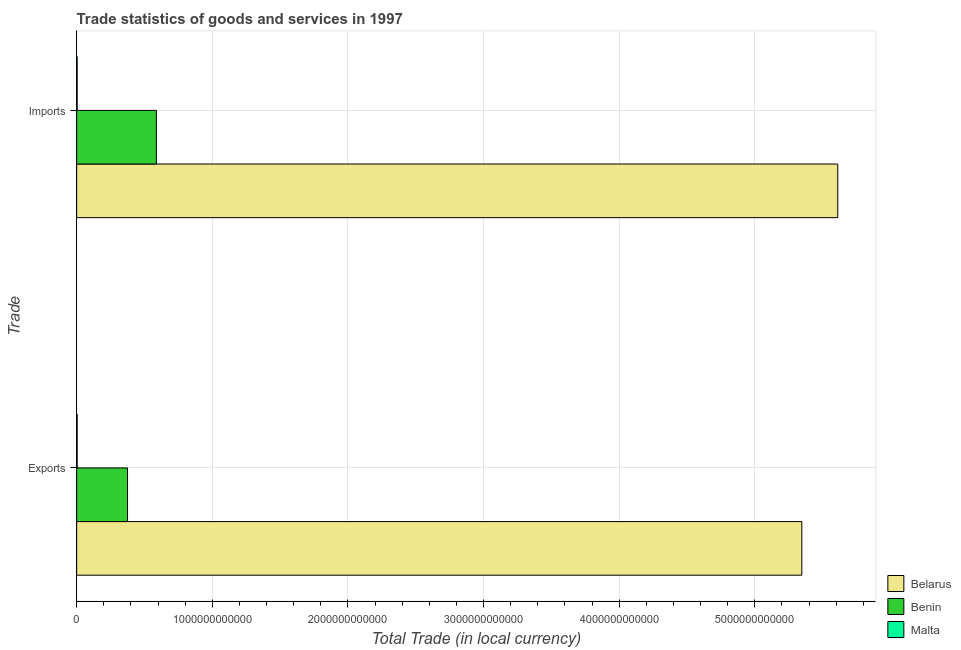How many different coloured bars are there?
Offer a terse response. 3. Are the number of bars per tick equal to the number of legend labels?
Your response must be concise. Yes. How many bars are there on the 2nd tick from the top?
Give a very brief answer. 3. How many bars are there on the 2nd tick from the bottom?
Provide a succinct answer. 3. What is the label of the 2nd group of bars from the top?
Offer a terse response. Exports. What is the imports of goods and services in Malta?
Offer a terse response. 3.81e+09. Across all countries, what is the maximum imports of goods and services?
Provide a succinct answer. 5.61e+12. Across all countries, what is the minimum imports of goods and services?
Your response must be concise. 3.81e+09. In which country was the imports of goods and services maximum?
Keep it short and to the point. Belarus. In which country was the export of goods and services minimum?
Provide a succinct answer. Malta. What is the total imports of goods and services in the graph?
Offer a terse response. 6.20e+12. What is the difference between the imports of goods and services in Benin and that in Belarus?
Your response must be concise. -5.02e+12. What is the difference between the imports of goods and services in Belarus and the export of goods and services in Benin?
Offer a terse response. 5.24e+12. What is the average imports of goods and services per country?
Keep it short and to the point. 2.07e+12. What is the difference between the export of goods and services and imports of goods and services in Belarus?
Keep it short and to the point. -2.65e+11. What is the ratio of the export of goods and services in Malta to that in Benin?
Give a very brief answer. 0.01. Is the imports of goods and services in Benin less than that in Belarus?
Give a very brief answer. Yes. In how many countries, is the imports of goods and services greater than the average imports of goods and services taken over all countries?
Provide a succinct answer. 1. What does the 2nd bar from the top in Exports represents?
Make the answer very short. Benin. What does the 3rd bar from the bottom in Exports represents?
Give a very brief answer. Malta. What is the difference between two consecutive major ticks on the X-axis?
Provide a short and direct response. 1.00e+12. Does the graph contain any zero values?
Provide a short and direct response. No. Does the graph contain grids?
Make the answer very short. Yes. Where does the legend appear in the graph?
Your response must be concise. Bottom right. How many legend labels are there?
Your answer should be very brief. 3. What is the title of the graph?
Offer a very short reply. Trade statistics of goods and services in 1997. Does "Qatar" appear as one of the legend labels in the graph?
Provide a succinct answer. No. What is the label or title of the X-axis?
Keep it short and to the point. Total Trade (in local currency). What is the label or title of the Y-axis?
Give a very brief answer. Trade. What is the Total Trade (in local currency) in Belarus in Exports?
Provide a succinct answer. 5.35e+12. What is the Total Trade (in local currency) in Benin in Exports?
Provide a succinct answer. 3.75e+11. What is the Total Trade (in local currency) of Malta in Exports?
Make the answer very short. 3.67e+09. What is the Total Trade (in local currency) of Belarus in Imports?
Keep it short and to the point. 5.61e+12. What is the Total Trade (in local currency) of Benin in Imports?
Your response must be concise. 5.88e+11. What is the Total Trade (in local currency) of Malta in Imports?
Make the answer very short. 3.81e+09. Across all Trade, what is the maximum Total Trade (in local currency) of Belarus?
Keep it short and to the point. 5.61e+12. Across all Trade, what is the maximum Total Trade (in local currency) in Benin?
Make the answer very short. 5.88e+11. Across all Trade, what is the maximum Total Trade (in local currency) in Malta?
Your answer should be compact. 3.81e+09. Across all Trade, what is the minimum Total Trade (in local currency) of Belarus?
Provide a short and direct response. 5.35e+12. Across all Trade, what is the minimum Total Trade (in local currency) in Benin?
Keep it short and to the point. 3.75e+11. Across all Trade, what is the minimum Total Trade (in local currency) of Malta?
Offer a terse response. 3.67e+09. What is the total Total Trade (in local currency) in Belarus in the graph?
Offer a terse response. 1.10e+13. What is the total Total Trade (in local currency) in Benin in the graph?
Make the answer very short. 9.63e+11. What is the total Total Trade (in local currency) of Malta in the graph?
Offer a very short reply. 7.48e+09. What is the difference between the Total Trade (in local currency) of Belarus in Exports and that in Imports?
Offer a very short reply. -2.65e+11. What is the difference between the Total Trade (in local currency) of Benin in Exports and that in Imports?
Provide a short and direct response. -2.13e+11. What is the difference between the Total Trade (in local currency) in Malta in Exports and that in Imports?
Your answer should be compact. -1.49e+08. What is the difference between the Total Trade (in local currency) in Belarus in Exports and the Total Trade (in local currency) in Benin in Imports?
Ensure brevity in your answer.  4.76e+12. What is the difference between the Total Trade (in local currency) of Belarus in Exports and the Total Trade (in local currency) of Malta in Imports?
Provide a succinct answer. 5.34e+12. What is the difference between the Total Trade (in local currency) of Benin in Exports and the Total Trade (in local currency) of Malta in Imports?
Give a very brief answer. 3.71e+11. What is the average Total Trade (in local currency) in Belarus per Trade?
Keep it short and to the point. 5.48e+12. What is the average Total Trade (in local currency) in Benin per Trade?
Make the answer very short. 4.81e+11. What is the average Total Trade (in local currency) of Malta per Trade?
Give a very brief answer. 3.74e+09. What is the difference between the Total Trade (in local currency) of Belarus and Total Trade (in local currency) of Benin in Exports?
Provide a short and direct response. 4.97e+12. What is the difference between the Total Trade (in local currency) of Belarus and Total Trade (in local currency) of Malta in Exports?
Offer a very short reply. 5.34e+12. What is the difference between the Total Trade (in local currency) of Benin and Total Trade (in local currency) of Malta in Exports?
Your response must be concise. 3.71e+11. What is the difference between the Total Trade (in local currency) in Belarus and Total Trade (in local currency) in Benin in Imports?
Ensure brevity in your answer.  5.02e+12. What is the difference between the Total Trade (in local currency) in Belarus and Total Trade (in local currency) in Malta in Imports?
Make the answer very short. 5.61e+12. What is the difference between the Total Trade (in local currency) in Benin and Total Trade (in local currency) in Malta in Imports?
Provide a short and direct response. 5.84e+11. What is the ratio of the Total Trade (in local currency) in Belarus in Exports to that in Imports?
Offer a terse response. 0.95. What is the ratio of the Total Trade (in local currency) in Benin in Exports to that in Imports?
Your answer should be compact. 0.64. What is the ratio of the Total Trade (in local currency) in Malta in Exports to that in Imports?
Your answer should be very brief. 0.96. What is the difference between the highest and the second highest Total Trade (in local currency) in Belarus?
Offer a very short reply. 2.65e+11. What is the difference between the highest and the second highest Total Trade (in local currency) in Benin?
Your response must be concise. 2.13e+11. What is the difference between the highest and the second highest Total Trade (in local currency) of Malta?
Make the answer very short. 1.49e+08. What is the difference between the highest and the lowest Total Trade (in local currency) of Belarus?
Your response must be concise. 2.65e+11. What is the difference between the highest and the lowest Total Trade (in local currency) of Benin?
Ensure brevity in your answer.  2.13e+11. What is the difference between the highest and the lowest Total Trade (in local currency) of Malta?
Offer a very short reply. 1.49e+08. 